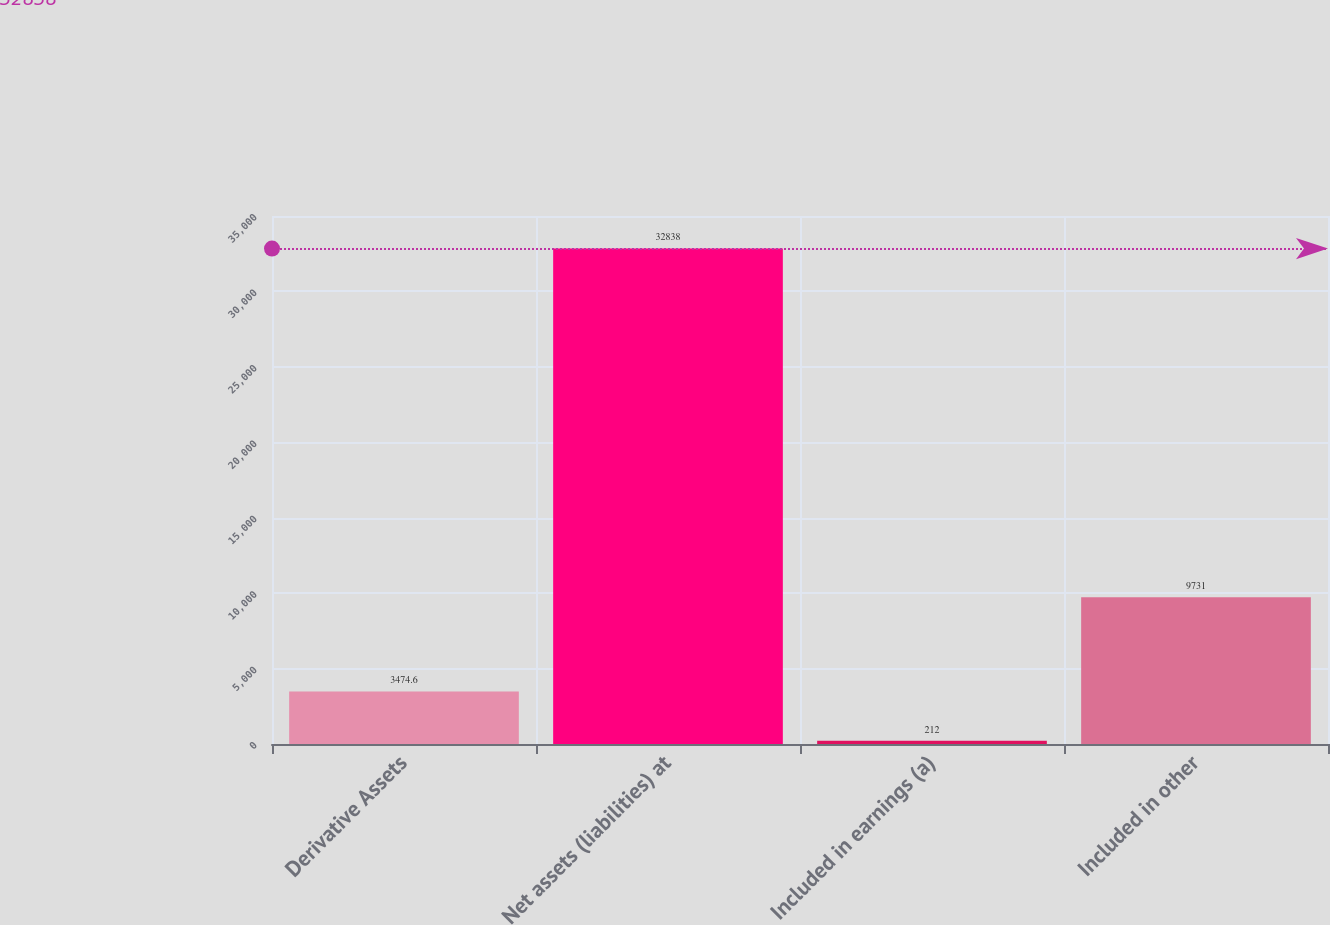Convert chart. <chart><loc_0><loc_0><loc_500><loc_500><bar_chart><fcel>Derivative Assets<fcel>Net assets (liabilities) at<fcel>Included in earnings (a)<fcel>Included in other<nl><fcel>3474.6<fcel>32838<fcel>212<fcel>9731<nl></chart> 